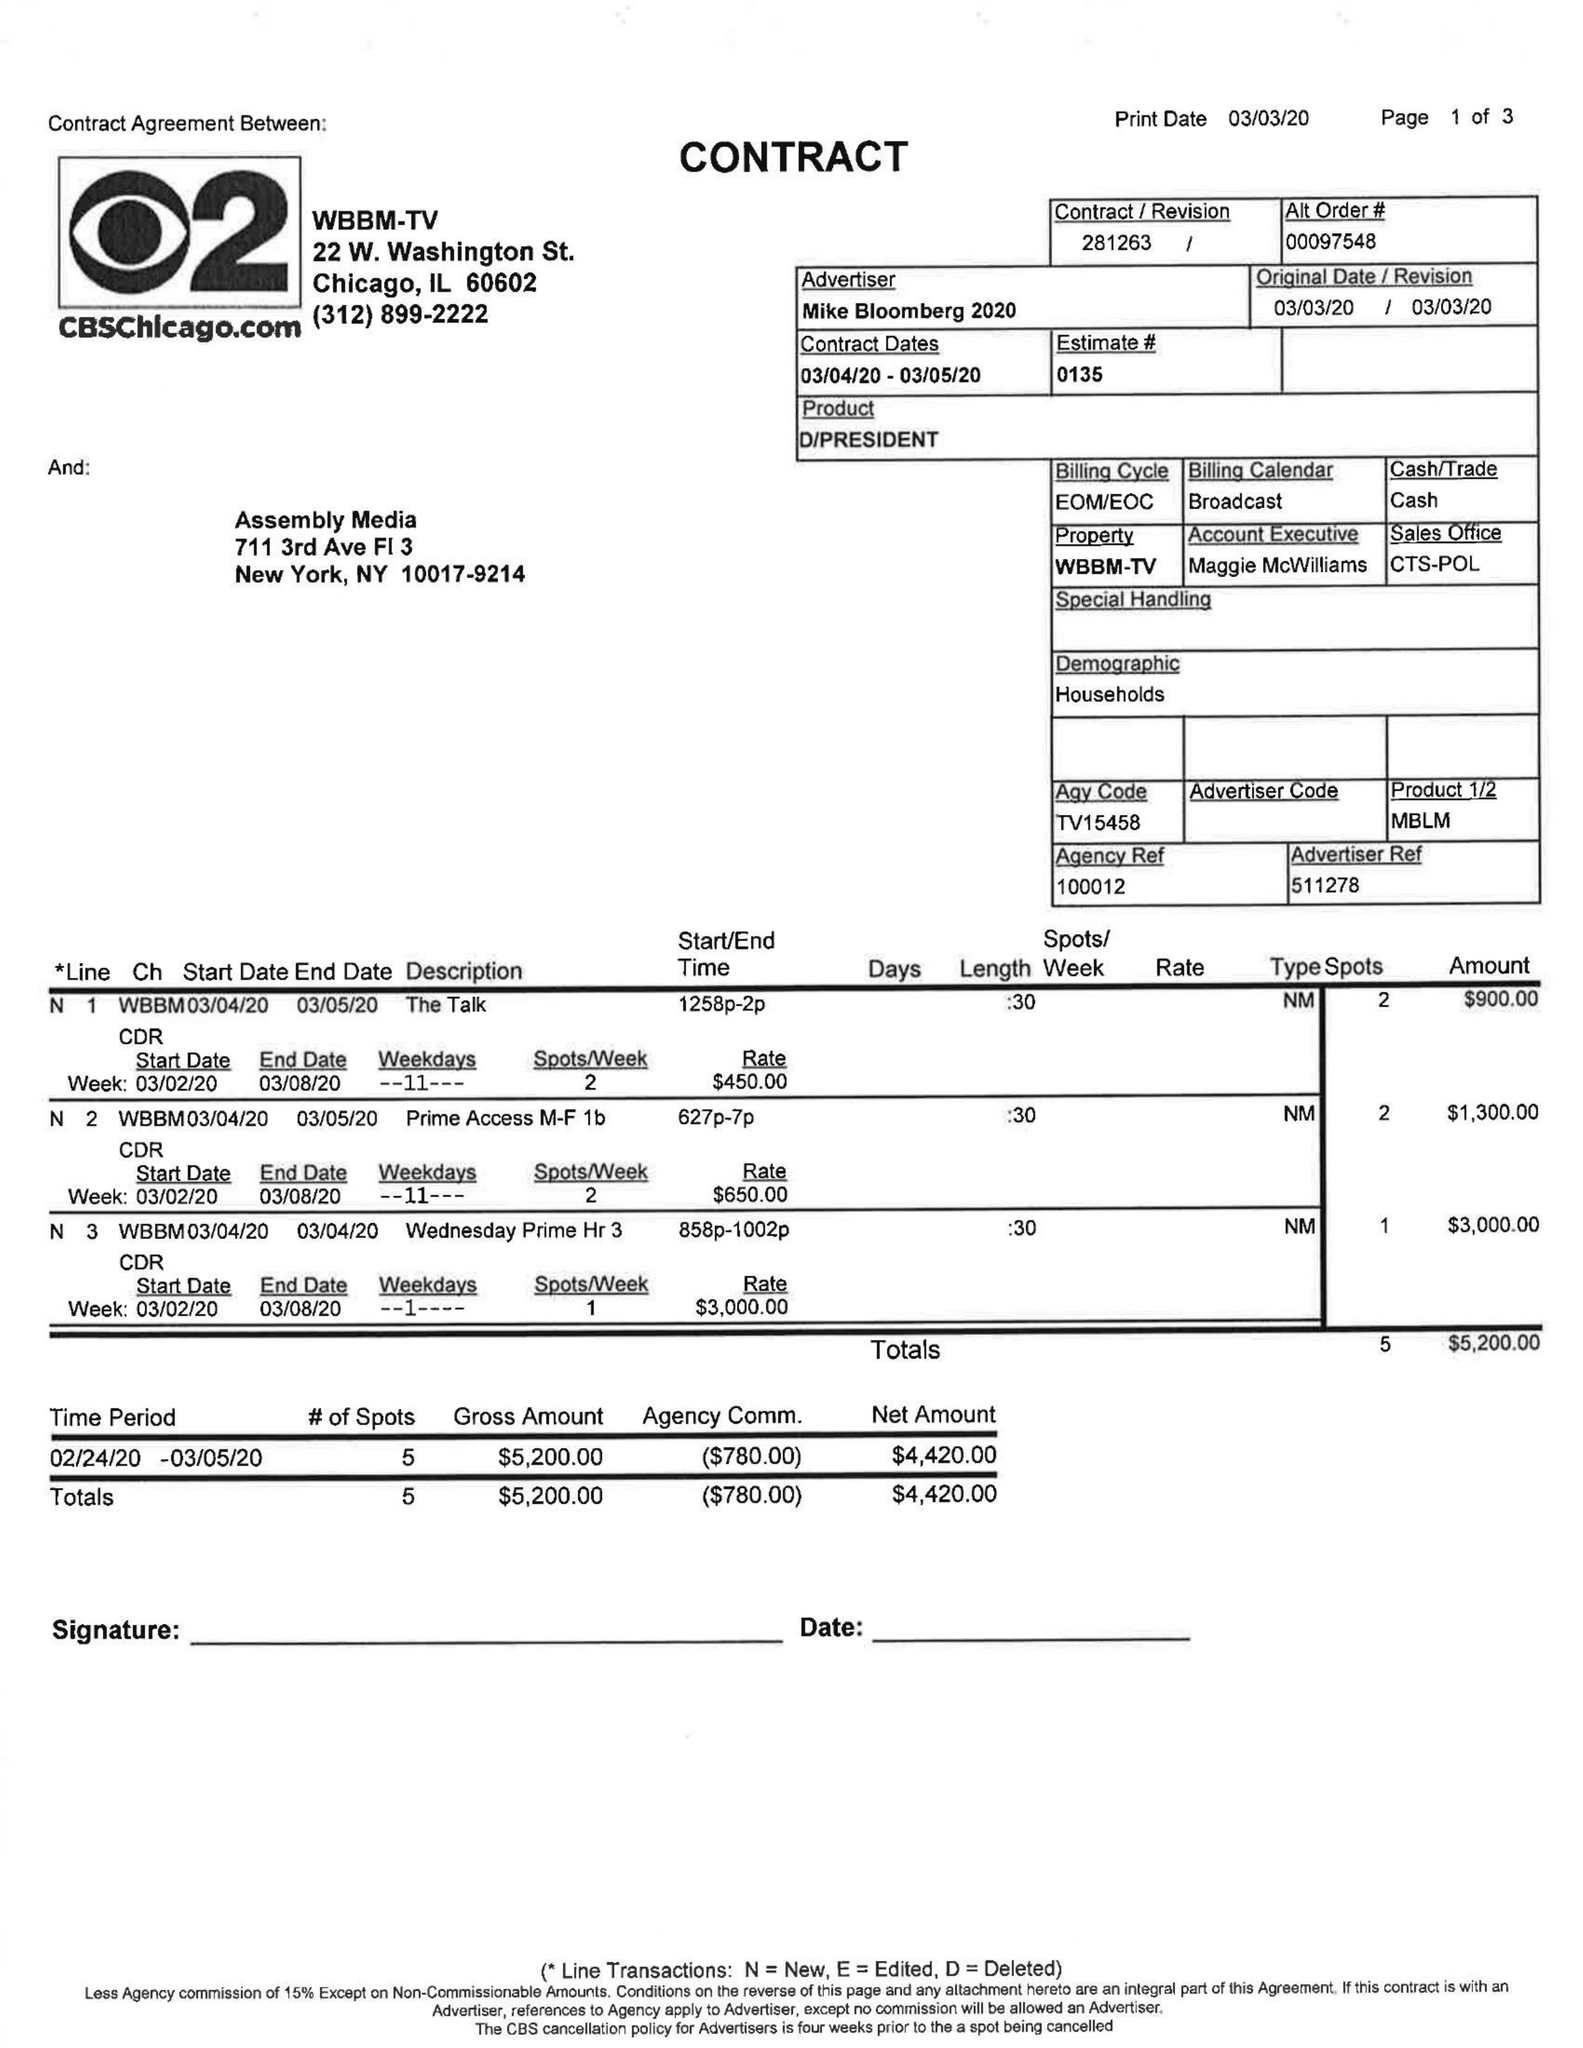What is the value for the gross_amount?
Answer the question using a single word or phrase. 5200.00 